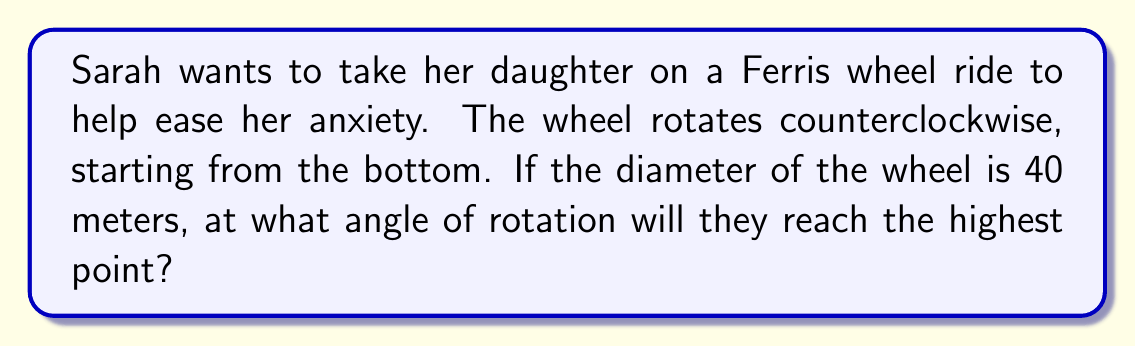Help me with this question. Let's approach this step-by-step:

1) First, we need to understand what the question is asking. We're looking for the angle of rotation from the starting position (bottom) to the highest point.

2) In a circle, the highest point is exactly opposite the lowest point. This means we're looking for a half rotation.

3) We know that a full rotation is 360°. Therefore, a half rotation would be:

   $$\frac{360°}{2} = 180°$$

4) Alternatively, we can think of this in terms of radians. A full rotation is $2\pi$ radians, so a half rotation would be:

   $$\frac{2\pi}{2} = \pi \text{ radians}$$

5) Converting from radians to degrees:

   $$\pi \text{ radians} = 180°$$

[asy]
import geometry;

size(200);
pair O=(0,0);
draw(circle(O,1));
draw((-1,0)--(1,0),dashed);
draw((0,-1)--(0,1),Arrow);
label("Start",(-1,0),W);
label("Highest point",(0,1),N);
draw(arc(O,1,0,180),Arrow);
label("180°",(0.5,0.5),NE);
[/asy]

Therefore, Sarah and her daughter will reach the highest point of the Ferris wheel after a rotation of 180° or $\pi$ radians.
Answer: 180° or $\pi$ radians 